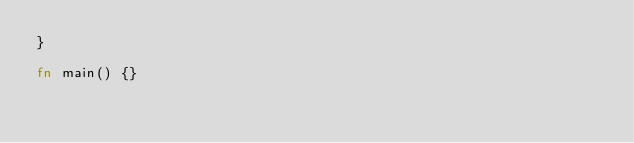Convert code to text. <code><loc_0><loc_0><loc_500><loc_500><_Rust_>}

fn main() {}
</code> 